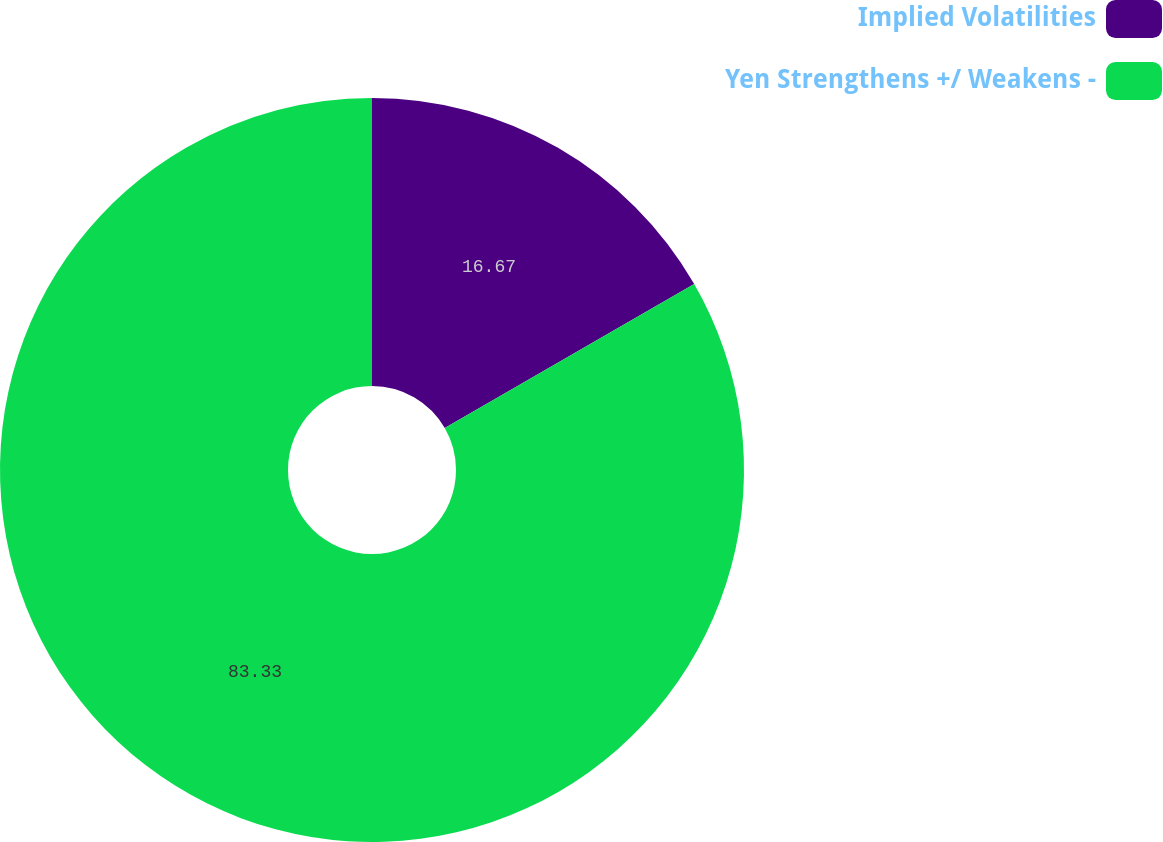<chart> <loc_0><loc_0><loc_500><loc_500><pie_chart><fcel>Implied Volatilities<fcel>Yen Strengthens +/ Weakens -<nl><fcel>16.67%<fcel>83.33%<nl></chart> 